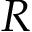Convert formula to latex. <formula><loc_0><loc_0><loc_500><loc_500>R</formula> 